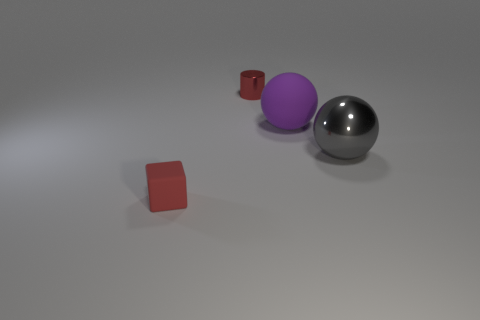How many metal things are the same color as the tiny block?
Provide a succinct answer. 1. What is the color of the big metallic object that is the same shape as the large purple rubber object?
Ensure brevity in your answer.  Gray. Is there any other thing that has the same shape as the purple rubber object?
Your answer should be compact. Yes. There is a gray metallic thing; is it the same shape as the object to the left of the small metallic thing?
Provide a succinct answer. No. What material is the gray object?
Your response must be concise. Metal. What is the size of the purple rubber object that is the same shape as the gray object?
Make the answer very short. Large. What number of other things are there of the same material as the tiny cylinder
Your answer should be compact. 1. Are the small cube and the big ball that is to the left of the gray ball made of the same material?
Give a very brief answer. Yes. Are there fewer tiny things to the right of the big gray ball than gray objects left of the small red shiny object?
Offer a very short reply. No. What color is the large object that is to the right of the purple matte sphere?
Keep it short and to the point. Gray. 